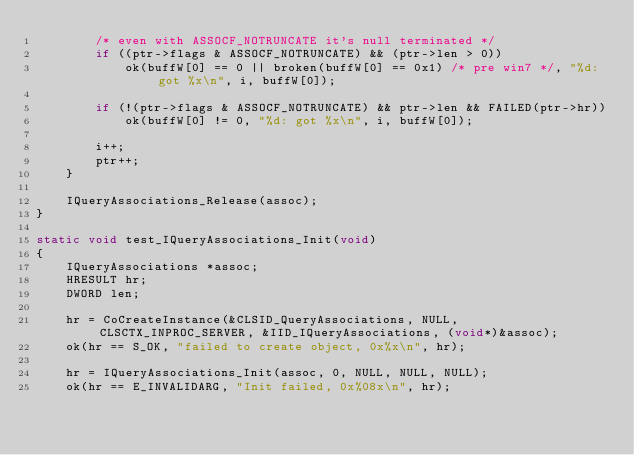Convert code to text. <code><loc_0><loc_0><loc_500><loc_500><_C_>        /* even with ASSOCF_NOTRUNCATE it's null terminated */
        if ((ptr->flags & ASSOCF_NOTRUNCATE) && (ptr->len > 0))
            ok(buffW[0] == 0 || broken(buffW[0] == 0x1) /* pre win7 */, "%d: got %x\n", i, buffW[0]);

        if (!(ptr->flags & ASSOCF_NOTRUNCATE) && ptr->len && FAILED(ptr->hr))
            ok(buffW[0] != 0, "%d: got %x\n", i, buffW[0]);

        i++;
        ptr++;
    }

    IQueryAssociations_Release(assoc);
}

static void test_IQueryAssociations_Init(void)
{
    IQueryAssociations *assoc;
    HRESULT hr;
    DWORD len;

    hr = CoCreateInstance(&CLSID_QueryAssociations, NULL, CLSCTX_INPROC_SERVER, &IID_IQueryAssociations, (void*)&assoc);
    ok(hr == S_OK, "failed to create object, 0x%x\n", hr);

    hr = IQueryAssociations_Init(assoc, 0, NULL, NULL, NULL);
    ok(hr == E_INVALIDARG, "Init failed, 0x%08x\n", hr);
</code> 